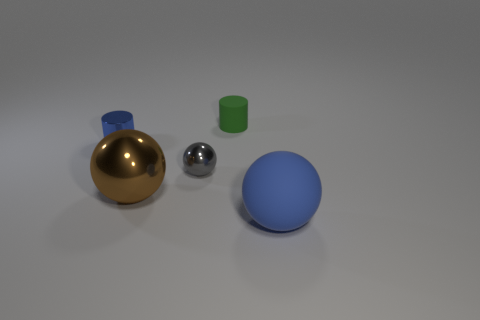There is a green object that is the same size as the gray metal ball; what material is it?
Offer a very short reply. Rubber. Is there a block that has the same size as the green matte object?
Your response must be concise. No. There is a cylinder that is behind the tiny blue object; what is its size?
Keep it short and to the point. Small. The brown object has what size?
Make the answer very short. Large. How many spheres are small gray metallic things or big blue rubber objects?
Give a very brief answer. 2. There is a green cylinder that is the same material as the blue sphere; what size is it?
Give a very brief answer. Small. What number of metallic balls are the same color as the matte cylinder?
Give a very brief answer. 0. There is a big brown metallic object; are there any rubber cylinders to the right of it?
Your answer should be very brief. Yes. Does the blue metallic thing have the same shape as the thing right of the tiny green object?
Provide a succinct answer. No. What number of objects are either cylinders that are to the left of the green object or gray metallic spheres?
Provide a succinct answer. 2. 